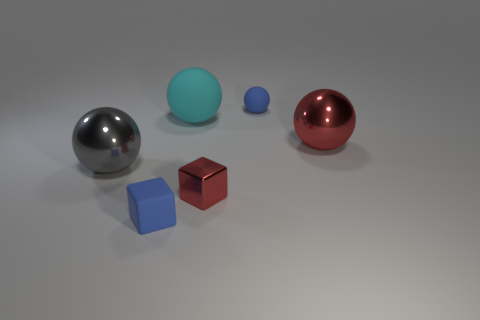There is a gray ball; is its size the same as the blue rubber object that is behind the blue matte block?
Your answer should be compact. No. What color is the sphere that is behind the large red object and on the left side of the small red object?
Ensure brevity in your answer.  Cyan. Is the number of tiny matte objects in front of the large red sphere greater than the number of gray metal spheres that are behind the big cyan matte ball?
Provide a short and direct response. Yes. The red cube that is made of the same material as the big red object is what size?
Provide a short and direct response. Small. There is a small blue matte thing that is behind the gray metal ball; how many big gray balls are right of it?
Your answer should be very brief. 0. Is there a large cyan thing of the same shape as the big gray shiny thing?
Ensure brevity in your answer.  Yes. There is a big metallic ball that is to the left of the big metallic thing that is behind the gray sphere; what color is it?
Your answer should be very brief. Gray. Is the number of small rubber things greater than the number of tiny objects?
Provide a succinct answer. No. What number of yellow matte cylinders are the same size as the cyan rubber thing?
Keep it short and to the point. 0. Are the big red object and the red thing on the left side of the big red metallic object made of the same material?
Provide a short and direct response. Yes. 